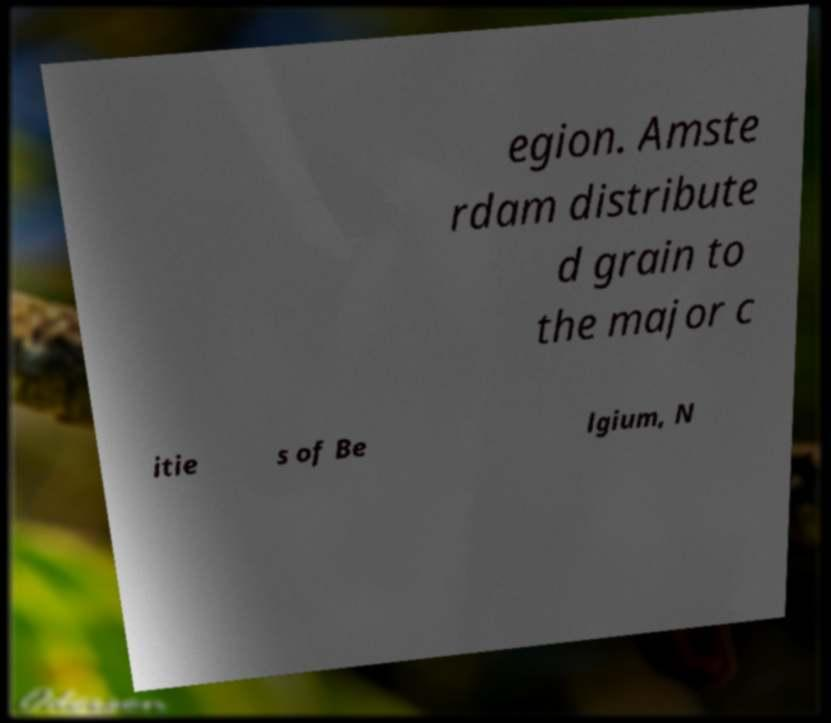Please read and relay the text visible in this image. What does it say? egion. Amste rdam distribute d grain to the major c itie s of Be lgium, N 